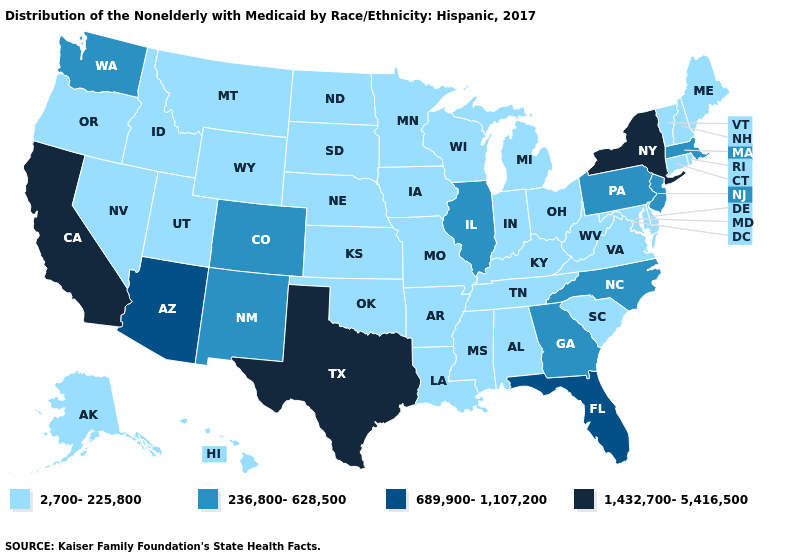Does New Jersey have the lowest value in the Northeast?
Be succinct. No. Name the states that have a value in the range 2,700-225,800?
Short answer required. Alabama, Alaska, Arkansas, Connecticut, Delaware, Hawaii, Idaho, Indiana, Iowa, Kansas, Kentucky, Louisiana, Maine, Maryland, Michigan, Minnesota, Mississippi, Missouri, Montana, Nebraska, Nevada, New Hampshire, North Dakota, Ohio, Oklahoma, Oregon, Rhode Island, South Carolina, South Dakota, Tennessee, Utah, Vermont, Virginia, West Virginia, Wisconsin, Wyoming. Which states have the lowest value in the USA?
Be succinct. Alabama, Alaska, Arkansas, Connecticut, Delaware, Hawaii, Idaho, Indiana, Iowa, Kansas, Kentucky, Louisiana, Maine, Maryland, Michigan, Minnesota, Mississippi, Missouri, Montana, Nebraska, Nevada, New Hampshire, North Dakota, Ohio, Oklahoma, Oregon, Rhode Island, South Carolina, South Dakota, Tennessee, Utah, Vermont, Virginia, West Virginia, Wisconsin, Wyoming. What is the lowest value in the USA?
Give a very brief answer. 2,700-225,800. What is the lowest value in states that border Nebraska?
Give a very brief answer. 2,700-225,800. Name the states that have a value in the range 1,432,700-5,416,500?
Quick response, please. California, New York, Texas. Among the states that border New York , which have the lowest value?
Quick response, please. Connecticut, Vermont. How many symbols are there in the legend?
Quick response, please. 4. Name the states that have a value in the range 236,800-628,500?
Write a very short answer. Colorado, Georgia, Illinois, Massachusetts, New Jersey, New Mexico, North Carolina, Pennsylvania, Washington. Does the first symbol in the legend represent the smallest category?
Answer briefly. Yes. Name the states that have a value in the range 689,900-1,107,200?
Give a very brief answer. Arizona, Florida. Name the states that have a value in the range 2,700-225,800?
Keep it brief. Alabama, Alaska, Arkansas, Connecticut, Delaware, Hawaii, Idaho, Indiana, Iowa, Kansas, Kentucky, Louisiana, Maine, Maryland, Michigan, Minnesota, Mississippi, Missouri, Montana, Nebraska, Nevada, New Hampshire, North Dakota, Ohio, Oklahoma, Oregon, Rhode Island, South Carolina, South Dakota, Tennessee, Utah, Vermont, Virginia, West Virginia, Wisconsin, Wyoming. Name the states that have a value in the range 236,800-628,500?
Concise answer only. Colorado, Georgia, Illinois, Massachusetts, New Jersey, New Mexico, North Carolina, Pennsylvania, Washington. Name the states that have a value in the range 1,432,700-5,416,500?
Short answer required. California, New York, Texas. Which states have the lowest value in the USA?
Write a very short answer. Alabama, Alaska, Arkansas, Connecticut, Delaware, Hawaii, Idaho, Indiana, Iowa, Kansas, Kentucky, Louisiana, Maine, Maryland, Michigan, Minnesota, Mississippi, Missouri, Montana, Nebraska, Nevada, New Hampshire, North Dakota, Ohio, Oklahoma, Oregon, Rhode Island, South Carolina, South Dakota, Tennessee, Utah, Vermont, Virginia, West Virginia, Wisconsin, Wyoming. 